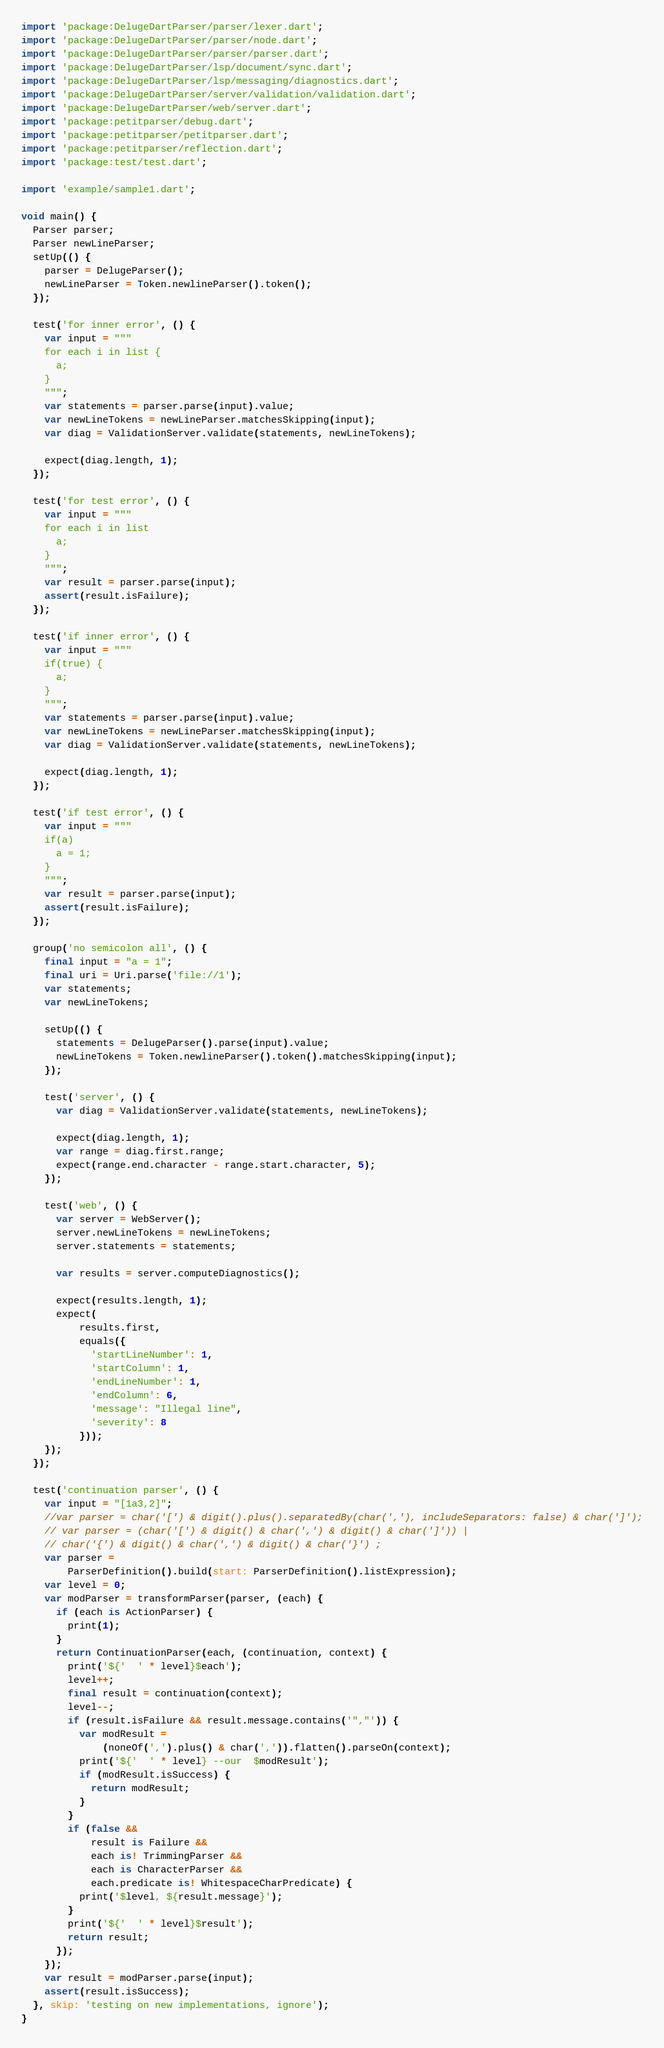<code> <loc_0><loc_0><loc_500><loc_500><_Dart_>import 'package:DelugeDartParser/parser/lexer.dart';
import 'package:DelugeDartParser/parser/node.dart';
import 'package:DelugeDartParser/parser/parser.dart';
import 'package:DelugeDartParser/lsp/document/sync.dart';
import 'package:DelugeDartParser/lsp/messaging/diagnostics.dart';
import 'package:DelugeDartParser/server/validation/validation.dart';
import 'package:DelugeDartParser/web/server.dart';
import 'package:petitparser/debug.dart';
import 'package:petitparser/petitparser.dart';
import 'package:petitparser/reflection.dart';
import 'package:test/test.dart';

import 'example/sample1.dart';

void main() {
  Parser parser;
  Parser newLineParser;
  setUp(() {
    parser = DelugeParser();
    newLineParser = Token.newlineParser().token();
  });

  test('for inner error', () {
    var input = """
    for each i in list {
      a;
    }
    """;
    var statements = parser.parse(input).value;
    var newLineTokens = newLineParser.matchesSkipping(input);
    var diag = ValidationServer.validate(statements, newLineTokens);

    expect(diag.length, 1);
  });

  test('for test error', () {
    var input = """
    for each i in list 
      a;
    }
    """;
    var result = parser.parse(input);
    assert(result.isFailure);
  });

  test('if inner error', () {
    var input = """
    if(true) {
      a;
    }
    """;
    var statements = parser.parse(input).value;
    var newLineTokens = newLineParser.matchesSkipping(input);
    var diag = ValidationServer.validate(statements, newLineTokens);

    expect(diag.length, 1);
  });

  test('if test error', () {
    var input = """
    if(a) 
      a = 1;
    }
    """;
    var result = parser.parse(input);
    assert(result.isFailure);
  });

  group('no semicolon all', () {
    final input = "a = 1";
    final uri = Uri.parse('file://1');
    var statements;
    var newLineTokens;

    setUp(() {
      statements = DelugeParser().parse(input).value;
      newLineTokens = Token.newlineParser().token().matchesSkipping(input);
    });

    test('server', () {
      var diag = ValidationServer.validate(statements, newLineTokens);

      expect(diag.length, 1);
      var range = diag.first.range;
      expect(range.end.character - range.start.character, 5);
    });

    test('web', () {
      var server = WebServer();
      server.newLineTokens = newLineTokens;
      server.statements = statements;

      var results = server.computeDiagnostics();

      expect(results.length, 1);
      expect(
          results.first,
          equals({
            'startLineNumber': 1,
            'startColumn': 1,
            'endLineNumber': 1,
            'endColumn': 6,
            'message': "Illegal line",
            'severity': 8
          }));
    });
  });

  test('continuation parser', () {
    var input = "[1a3,2]";
    //var parser = char('[') & digit().plus().separatedBy(char(','), includeSeparators: false) & char(']');
    // var parser = (char('[') & digit() & char(',') & digit() & char(']')) |
    // char('{') & digit() & char(',') & digit() & char('}') ;
    var parser =
        ParserDefinition().build(start: ParserDefinition().listExpression);
    var level = 0;
    var modParser = transformParser(parser, (each) {
      if (each is ActionParser) {
        print(1);
      }
      return ContinuationParser(each, (continuation, context) {
        print('${'  ' * level}$each');
        level++;
        final result = continuation(context);
        level--;
        if (result.isFailure && result.message.contains('","')) {
          var modResult =
              (noneOf(',').plus() & char(',')).flatten().parseOn(context);
          print('${'  ' * level} --our  $modResult');
          if (modResult.isSuccess) {
            return modResult;
          }
        }
        if (false &&
            result is Failure &&
            each is! TrimmingParser &&
            each is CharacterParser &&
            each.predicate is! WhitespaceCharPredicate) {
          print('$level, ${result.message}');
        }
        print('${'  ' * level}$result');
        return result;
      });
    });
    var result = modParser.parse(input);
    assert(result.isSuccess);
  }, skip: 'testing on new implementations, ignore');
}
</code> 